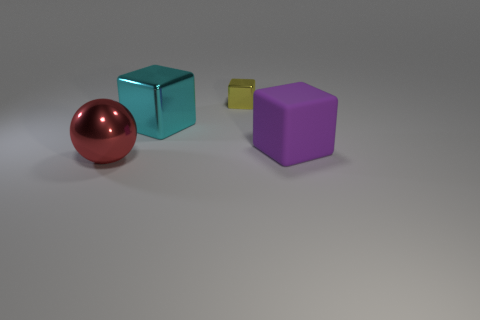What number of objects are small yellow shiny cylinders or small blocks? In the image, there are no small yellow shiny cylinders. However, there is one small block, which is yellow and has a cubic shape. 